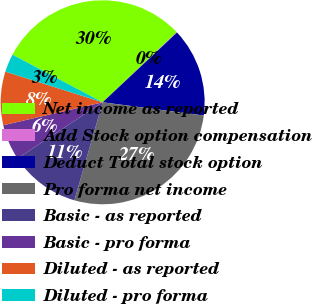Convert chart to OTSL. <chart><loc_0><loc_0><loc_500><loc_500><pie_chart><fcel>Net income as reported<fcel>Add Stock option compensation<fcel>Deduct Total stock option<fcel>Pro forma net income<fcel>Basic - as reported<fcel>Basic - pro forma<fcel>Diluted - as reported<fcel>Diluted - pro forma<nl><fcel>30.2%<fcel>0.08%<fcel>14.06%<fcel>27.4%<fcel>11.26%<fcel>5.67%<fcel>8.47%<fcel>2.87%<nl></chart> 